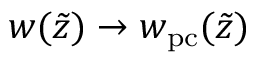<formula> <loc_0><loc_0><loc_500><loc_500>w ( \tilde { z } ) \rightarrow w _ { p c } ( \tilde { z } )</formula> 